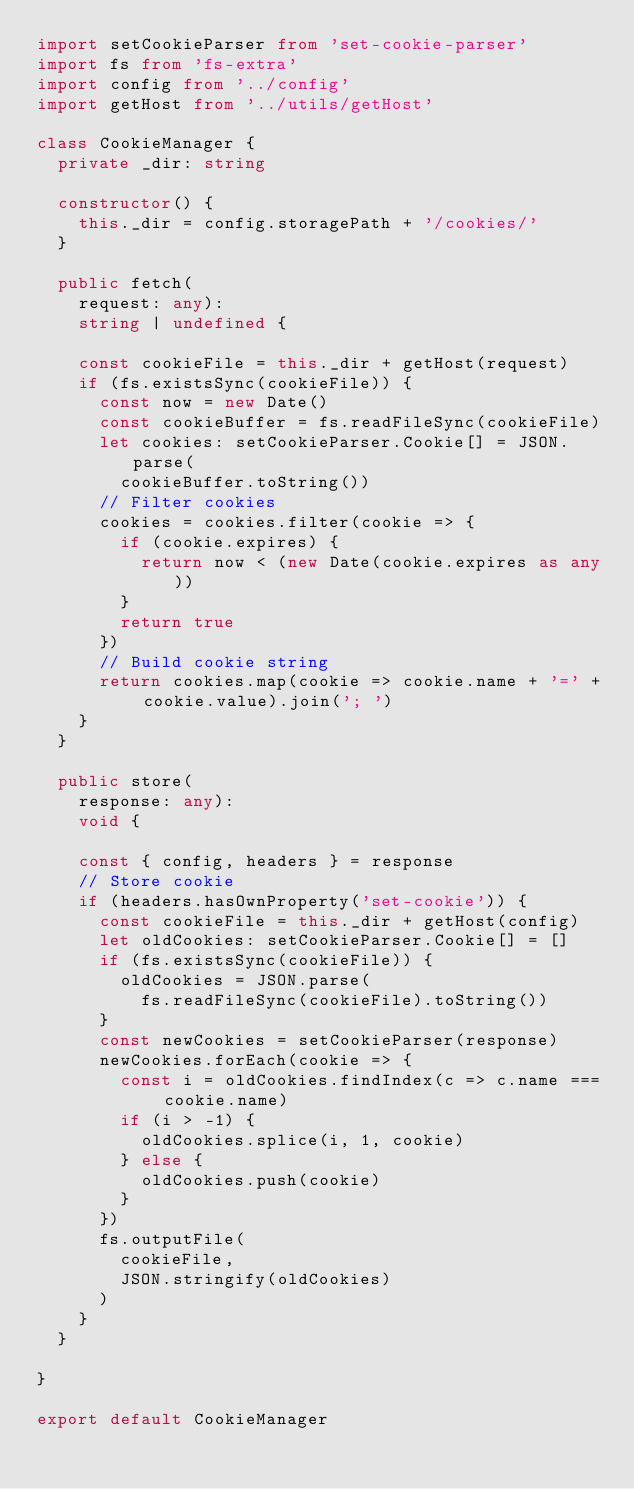<code> <loc_0><loc_0><loc_500><loc_500><_TypeScript_>import setCookieParser from 'set-cookie-parser'
import fs from 'fs-extra'
import config from '../config'
import getHost from '../utils/getHost'

class CookieManager {
  private _dir: string

  constructor() {
    this._dir = config.storagePath + '/cookies/'
  }

  public fetch(
    request: any):
    string | undefined {

    const cookieFile = this._dir + getHost(request)
    if (fs.existsSync(cookieFile)) {
      const now = new Date()
      const cookieBuffer = fs.readFileSync(cookieFile)
      let cookies: setCookieParser.Cookie[] = JSON.parse(
        cookieBuffer.toString())
      // Filter cookies
      cookies = cookies.filter(cookie => {
        if (cookie.expires) {
          return now < (new Date(cookie.expires as any))
        }
        return true
      })
      // Build cookie string
      return cookies.map(cookie => cookie.name + '=' + cookie.value).join('; ')
    }
  }

  public store(
    response: any):
    void {

    const { config, headers } = response
    // Store cookie
    if (headers.hasOwnProperty('set-cookie')) {
      const cookieFile = this._dir + getHost(config)
      let oldCookies: setCookieParser.Cookie[] = []
      if (fs.existsSync(cookieFile)) {
        oldCookies = JSON.parse(
          fs.readFileSync(cookieFile).toString())
      }
      const newCookies = setCookieParser(response)
      newCookies.forEach(cookie => {
        const i = oldCookies.findIndex(c => c.name === cookie.name)
        if (i > -1) {
          oldCookies.splice(i, 1, cookie)
        } else {
          oldCookies.push(cookie)
        }
      })
      fs.outputFile(
        cookieFile,
        JSON.stringify(oldCookies)
      )
    }
  }

}

export default CookieManager</code> 